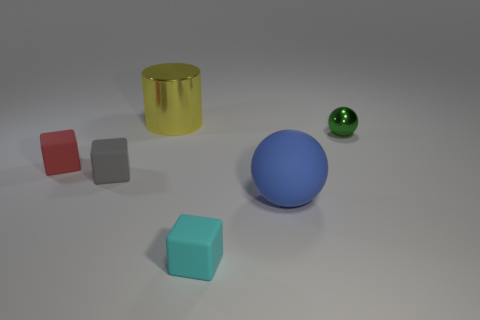Add 4 big balls. How many objects exist? 10 Subtract all cylinders. How many objects are left? 5 Add 3 big purple rubber cylinders. How many big purple rubber cylinders exist? 3 Subtract 0 purple spheres. How many objects are left? 6 Subtract all large cyan rubber balls. Subtract all gray objects. How many objects are left? 5 Add 5 small blocks. How many small blocks are left? 8 